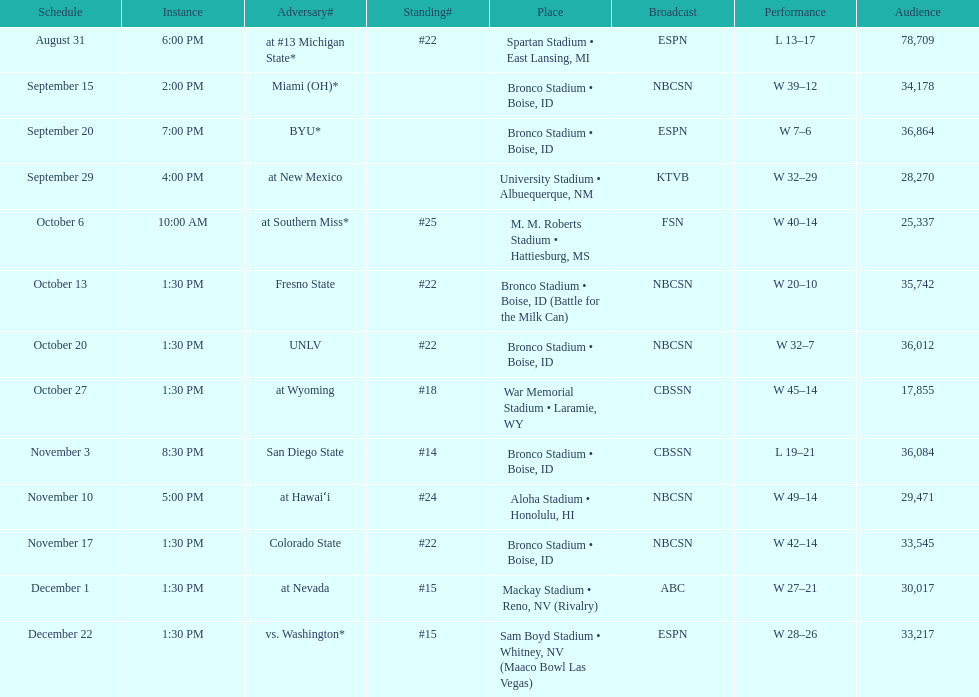Which team has the highest rank among those listed? San Diego State. I'm looking to parse the entire table for insights. Could you assist me with that? {'header': ['Schedule', 'Instance', 'Adversary#', 'Standing#', 'Place', 'Broadcast', 'Performance', 'Audience'], 'rows': [['August 31', '6:00 PM', 'at\xa0#13\xa0Michigan State*', '#22', 'Spartan Stadium • East Lansing, MI', 'ESPN', 'L\xa013–17', '78,709'], ['September 15', '2:00 PM', 'Miami (OH)*', '', 'Bronco Stadium • Boise, ID', 'NBCSN', 'W\xa039–12', '34,178'], ['September 20', '7:00 PM', 'BYU*', '', 'Bronco Stadium • Boise, ID', 'ESPN', 'W\xa07–6', '36,864'], ['September 29', '4:00 PM', 'at\xa0New Mexico', '', 'University Stadium • Albuequerque, NM', 'KTVB', 'W\xa032–29', '28,270'], ['October 6', '10:00 AM', 'at\xa0Southern Miss*', '#25', 'M. M. Roberts Stadium • Hattiesburg, MS', 'FSN', 'W\xa040–14', '25,337'], ['October 13', '1:30 PM', 'Fresno State', '#22', 'Bronco Stadium • Boise, ID (Battle for the Milk Can)', 'NBCSN', 'W\xa020–10', '35,742'], ['October 20', '1:30 PM', 'UNLV', '#22', 'Bronco Stadium • Boise, ID', 'NBCSN', 'W\xa032–7', '36,012'], ['October 27', '1:30 PM', 'at\xa0Wyoming', '#18', 'War Memorial Stadium • Laramie, WY', 'CBSSN', 'W\xa045–14', '17,855'], ['November 3', '8:30 PM', 'San Diego State', '#14', 'Bronco Stadium • Boise, ID', 'CBSSN', 'L\xa019–21', '36,084'], ['November 10', '5:00 PM', 'at\xa0Hawaiʻi', '#24', 'Aloha Stadium • Honolulu, HI', 'NBCSN', 'W\xa049–14', '29,471'], ['November 17', '1:30 PM', 'Colorado State', '#22', 'Bronco Stadium • Boise, ID', 'NBCSN', 'W\xa042–14', '33,545'], ['December 1', '1:30 PM', 'at\xa0Nevada', '#15', 'Mackay Stadium • Reno, NV (Rivalry)', 'ABC', 'W\xa027–21', '30,017'], ['December 22', '1:30 PM', 'vs.\xa0Washington*', '#15', 'Sam Boyd Stadium • Whitney, NV (Maaco Bowl Las Vegas)', 'ESPN', 'W\xa028–26', '33,217']]} 